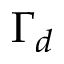Convert formula to latex. <formula><loc_0><loc_0><loc_500><loc_500>\Gamma _ { d }</formula> 